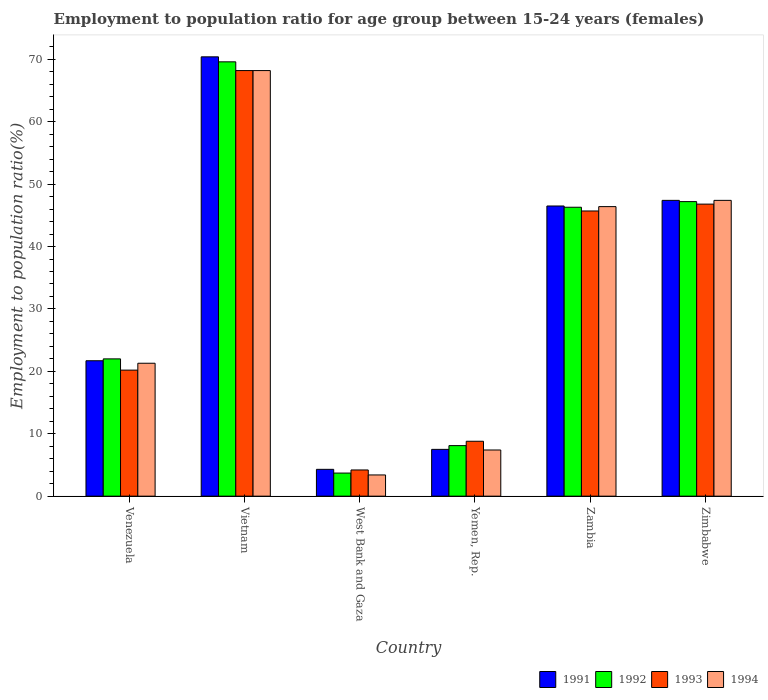How many groups of bars are there?
Make the answer very short. 6. Are the number of bars per tick equal to the number of legend labels?
Keep it short and to the point. Yes. Are the number of bars on each tick of the X-axis equal?
Make the answer very short. Yes. What is the label of the 4th group of bars from the left?
Offer a terse response. Yemen, Rep. What is the employment to population ratio in 1991 in Zimbabwe?
Your answer should be compact. 47.4. Across all countries, what is the maximum employment to population ratio in 1991?
Offer a very short reply. 70.4. Across all countries, what is the minimum employment to population ratio in 1991?
Your answer should be very brief. 4.3. In which country was the employment to population ratio in 1992 maximum?
Ensure brevity in your answer.  Vietnam. In which country was the employment to population ratio in 1991 minimum?
Offer a very short reply. West Bank and Gaza. What is the total employment to population ratio in 1991 in the graph?
Give a very brief answer. 197.8. What is the difference between the employment to population ratio in 1991 in Yemen, Rep. and that in Zambia?
Ensure brevity in your answer.  -39. What is the difference between the employment to population ratio in 1994 in Zambia and the employment to population ratio in 1992 in Zimbabwe?
Your answer should be compact. -0.8. What is the average employment to population ratio in 1993 per country?
Keep it short and to the point. 32.32. In how many countries, is the employment to population ratio in 1992 greater than 60 %?
Provide a short and direct response. 1. What is the ratio of the employment to population ratio in 1994 in Vietnam to that in Zimbabwe?
Ensure brevity in your answer.  1.44. What is the difference between the highest and the second highest employment to population ratio in 1992?
Provide a short and direct response. 23.3. What is the difference between the highest and the lowest employment to population ratio in 1991?
Your answer should be very brief. 66.1. Is the sum of the employment to population ratio in 1991 in Venezuela and Yemen, Rep. greater than the maximum employment to population ratio in 1992 across all countries?
Offer a terse response. No. How many bars are there?
Your response must be concise. 24. Are the values on the major ticks of Y-axis written in scientific E-notation?
Keep it short and to the point. No. Does the graph contain any zero values?
Provide a short and direct response. No. Does the graph contain grids?
Ensure brevity in your answer.  No. Where does the legend appear in the graph?
Ensure brevity in your answer.  Bottom right. How are the legend labels stacked?
Ensure brevity in your answer.  Horizontal. What is the title of the graph?
Your answer should be compact. Employment to population ratio for age group between 15-24 years (females). Does "1988" appear as one of the legend labels in the graph?
Your answer should be very brief. No. What is the Employment to population ratio(%) of 1991 in Venezuela?
Ensure brevity in your answer.  21.7. What is the Employment to population ratio(%) of 1992 in Venezuela?
Give a very brief answer. 22. What is the Employment to population ratio(%) in 1993 in Venezuela?
Your answer should be compact. 20.2. What is the Employment to population ratio(%) in 1994 in Venezuela?
Your answer should be very brief. 21.3. What is the Employment to population ratio(%) of 1991 in Vietnam?
Your answer should be very brief. 70.4. What is the Employment to population ratio(%) in 1992 in Vietnam?
Your answer should be very brief. 69.6. What is the Employment to population ratio(%) in 1993 in Vietnam?
Offer a very short reply. 68.2. What is the Employment to population ratio(%) in 1994 in Vietnam?
Provide a succinct answer. 68.2. What is the Employment to population ratio(%) of 1991 in West Bank and Gaza?
Ensure brevity in your answer.  4.3. What is the Employment to population ratio(%) of 1992 in West Bank and Gaza?
Your response must be concise. 3.7. What is the Employment to population ratio(%) of 1993 in West Bank and Gaza?
Make the answer very short. 4.2. What is the Employment to population ratio(%) of 1994 in West Bank and Gaza?
Make the answer very short. 3.4. What is the Employment to population ratio(%) of 1991 in Yemen, Rep.?
Offer a very short reply. 7.5. What is the Employment to population ratio(%) of 1992 in Yemen, Rep.?
Your response must be concise. 8.1. What is the Employment to population ratio(%) in 1993 in Yemen, Rep.?
Keep it short and to the point. 8.8. What is the Employment to population ratio(%) of 1994 in Yemen, Rep.?
Ensure brevity in your answer.  7.4. What is the Employment to population ratio(%) in 1991 in Zambia?
Your answer should be compact. 46.5. What is the Employment to population ratio(%) in 1992 in Zambia?
Your answer should be compact. 46.3. What is the Employment to population ratio(%) in 1993 in Zambia?
Your response must be concise. 45.7. What is the Employment to population ratio(%) of 1994 in Zambia?
Your answer should be very brief. 46.4. What is the Employment to population ratio(%) of 1991 in Zimbabwe?
Your response must be concise. 47.4. What is the Employment to population ratio(%) in 1992 in Zimbabwe?
Your answer should be compact. 47.2. What is the Employment to population ratio(%) in 1993 in Zimbabwe?
Ensure brevity in your answer.  46.8. What is the Employment to population ratio(%) in 1994 in Zimbabwe?
Provide a succinct answer. 47.4. Across all countries, what is the maximum Employment to population ratio(%) of 1991?
Provide a succinct answer. 70.4. Across all countries, what is the maximum Employment to population ratio(%) of 1992?
Offer a very short reply. 69.6. Across all countries, what is the maximum Employment to population ratio(%) in 1993?
Provide a short and direct response. 68.2. Across all countries, what is the maximum Employment to population ratio(%) of 1994?
Ensure brevity in your answer.  68.2. Across all countries, what is the minimum Employment to population ratio(%) of 1991?
Keep it short and to the point. 4.3. Across all countries, what is the minimum Employment to population ratio(%) in 1992?
Make the answer very short. 3.7. Across all countries, what is the minimum Employment to population ratio(%) of 1993?
Your response must be concise. 4.2. Across all countries, what is the minimum Employment to population ratio(%) of 1994?
Offer a terse response. 3.4. What is the total Employment to population ratio(%) in 1991 in the graph?
Your answer should be very brief. 197.8. What is the total Employment to population ratio(%) of 1992 in the graph?
Provide a short and direct response. 196.9. What is the total Employment to population ratio(%) in 1993 in the graph?
Offer a very short reply. 193.9. What is the total Employment to population ratio(%) of 1994 in the graph?
Your response must be concise. 194.1. What is the difference between the Employment to population ratio(%) of 1991 in Venezuela and that in Vietnam?
Your response must be concise. -48.7. What is the difference between the Employment to population ratio(%) of 1992 in Venezuela and that in Vietnam?
Make the answer very short. -47.6. What is the difference between the Employment to population ratio(%) of 1993 in Venezuela and that in Vietnam?
Make the answer very short. -48. What is the difference between the Employment to population ratio(%) of 1994 in Venezuela and that in Vietnam?
Your answer should be compact. -46.9. What is the difference between the Employment to population ratio(%) of 1994 in Venezuela and that in West Bank and Gaza?
Your answer should be compact. 17.9. What is the difference between the Employment to population ratio(%) of 1992 in Venezuela and that in Yemen, Rep.?
Offer a terse response. 13.9. What is the difference between the Employment to population ratio(%) in 1993 in Venezuela and that in Yemen, Rep.?
Provide a short and direct response. 11.4. What is the difference between the Employment to population ratio(%) of 1991 in Venezuela and that in Zambia?
Your answer should be compact. -24.8. What is the difference between the Employment to population ratio(%) of 1992 in Venezuela and that in Zambia?
Offer a terse response. -24.3. What is the difference between the Employment to population ratio(%) of 1993 in Venezuela and that in Zambia?
Your answer should be compact. -25.5. What is the difference between the Employment to population ratio(%) of 1994 in Venezuela and that in Zambia?
Your response must be concise. -25.1. What is the difference between the Employment to population ratio(%) of 1991 in Venezuela and that in Zimbabwe?
Your response must be concise. -25.7. What is the difference between the Employment to population ratio(%) of 1992 in Venezuela and that in Zimbabwe?
Provide a succinct answer. -25.2. What is the difference between the Employment to population ratio(%) of 1993 in Venezuela and that in Zimbabwe?
Provide a succinct answer. -26.6. What is the difference between the Employment to population ratio(%) of 1994 in Venezuela and that in Zimbabwe?
Provide a short and direct response. -26.1. What is the difference between the Employment to population ratio(%) of 1991 in Vietnam and that in West Bank and Gaza?
Your response must be concise. 66.1. What is the difference between the Employment to population ratio(%) of 1992 in Vietnam and that in West Bank and Gaza?
Your answer should be very brief. 65.9. What is the difference between the Employment to population ratio(%) of 1993 in Vietnam and that in West Bank and Gaza?
Provide a short and direct response. 64. What is the difference between the Employment to population ratio(%) of 1994 in Vietnam and that in West Bank and Gaza?
Your answer should be compact. 64.8. What is the difference between the Employment to population ratio(%) in 1991 in Vietnam and that in Yemen, Rep.?
Make the answer very short. 62.9. What is the difference between the Employment to population ratio(%) of 1992 in Vietnam and that in Yemen, Rep.?
Make the answer very short. 61.5. What is the difference between the Employment to population ratio(%) of 1993 in Vietnam and that in Yemen, Rep.?
Make the answer very short. 59.4. What is the difference between the Employment to population ratio(%) of 1994 in Vietnam and that in Yemen, Rep.?
Offer a very short reply. 60.8. What is the difference between the Employment to population ratio(%) in 1991 in Vietnam and that in Zambia?
Your answer should be very brief. 23.9. What is the difference between the Employment to population ratio(%) of 1992 in Vietnam and that in Zambia?
Your answer should be compact. 23.3. What is the difference between the Employment to population ratio(%) in 1994 in Vietnam and that in Zambia?
Ensure brevity in your answer.  21.8. What is the difference between the Employment to population ratio(%) of 1991 in Vietnam and that in Zimbabwe?
Offer a terse response. 23. What is the difference between the Employment to population ratio(%) of 1992 in Vietnam and that in Zimbabwe?
Your answer should be very brief. 22.4. What is the difference between the Employment to population ratio(%) in 1993 in Vietnam and that in Zimbabwe?
Your response must be concise. 21.4. What is the difference between the Employment to population ratio(%) of 1994 in Vietnam and that in Zimbabwe?
Your answer should be compact. 20.8. What is the difference between the Employment to population ratio(%) in 1992 in West Bank and Gaza and that in Yemen, Rep.?
Provide a succinct answer. -4.4. What is the difference between the Employment to population ratio(%) in 1994 in West Bank and Gaza and that in Yemen, Rep.?
Provide a short and direct response. -4. What is the difference between the Employment to population ratio(%) of 1991 in West Bank and Gaza and that in Zambia?
Your response must be concise. -42.2. What is the difference between the Employment to population ratio(%) of 1992 in West Bank and Gaza and that in Zambia?
Your response must be concise. -42.6. What is the difference between the Employment to population ratio(%) in 1993 in West Bank and Gaza and that in Zambia?
Ensure brevity in your answer.  -41.5. What is the difference between the Employment to population ratio(%) of 1994 in West Bank and Gaza and that in Zambia?
Make the answer very short. -43. What is the difference between the Employment to population ratio(%) of 1991 in West Bank and Gaza and that in Zimbabwe?
Provide a short and direct response. -43.1. What is the difference between the Employment to population ratio(%) in 1992 in West Bank and Gaza and that in Zimbabwe?
Your response must be concise. -43.5. What is the difference between the Employment to population ratio(%) of 1993 in West Bank and Gaza and that in Zimbabwe?
Provide a succinct answer. -42.6. What is the difference between the Employment to population ratio(%) in 1994 in West Bank and Gaza and that in Zimbabwe?
Provide a succinct answer. -44. What is the difference between the Employment to population ratio(%) in 1991 in Yemen, Rep. and that in Zambia?
Your answer should be very brief. -39. What is the difference between the Employment to population ratio(%) in 1992 in Yemen, Rep. and that in Zambia?
Provide a succinct answer. -38.2. What is the difference between the Employment to population ratio(%) of 1993 in Yemen, Rep. and that in Zambia?
Your answer should be very brief. -36.9. What is the difference between the Employment to population ratio(%) in 1994 in Yemen, Rep. and that in Zambia?
Your response must be concise. -39. What is the difference between the Employment to population ratio(%) of 1991 in Yemen, Rep. and that in Zimbabwe?
Keep it short and to the point. -39.9. What is the difference between the Employment to population ratio(%) in 1992 in Yemen, Rep. and that in Zimbabwe?
Your response must be concise. -39.1. What is the difference between the Employment to population ratio(%) in 1993 in Yemen, Rep. and that in Zimbabwe?
Offer a terse response. -38. What is the difference between the Employment to population ratio(%) in 1994 in Yemen, Rep. and that in Zimbabwe?
Ensure brevity in your answer.  -40. What is the difference between the Employment to population ratio(%) in 1992 in Zambia and that in Zimbabwe?
Offer a terse response. -0.9. What is the difference between the Employment to population ratio(%) in 1993 in Zambia and that in Zimbabwe?
Your answer should be compact. -1.1. What is the difference between the Employment to population ratio(%) of 1994 in Zambia and that in Zimbabwe?
Ensure brevity in your answer.  -1. What is the difference between the Employment to population ratio(%) in 1991 in Venezuela and the Employment to population ratio(%) in 1992 in Vietnam?
Your answer should be very brief. -47.9. What is the difference between the Employment to population ratio(%) in 1991 in Venezuela and the Employment to population ratio(%) in 1993 in Vietnam?
Your answer should be very brief. -46.5. What is the difference between the Employment to population ratio(%) of 1991 in Venezuela and the Employment to population ratio(%) of 1994 in Vietnam?
Your answer should be compact. -46.5. What is the difference between the Employment to population ratio(%) in 1992 in Venezuela and the Employment to population ratio(%) in 1993 in Vietnam?
Your answer should be very brief. -46.2. What is the difference between the Employment to population ratio(%) in 1992 in Venezuela and the Employment to population ratio(%) in 1994 in Vietnam?
Offer a terse response. -46.2. What is the difference between the Employment to population ratio(%) in 1993 in Venezuela and the Employment to population ratio(%) in 1994 in Vietnam?
Provide a short and direct response. -48. What is the difference between the Employment to population ratio(%) of 1992 in Venezuela and the Employment to population ratio(%) of 1994 in West Bank and Gaza?
Ensure brevity in your answer.  18.6. What is the difference between the Employment to population ratio(%) of 1991 in Venezuela and the Employment to population ratio(%) of 1992 in Yemen, Rep.?
Your response must be concise. 13.6. What is the difference between the Employment to population ratio(%) in 1991 in Venezuela and the Employment to population ratio(%) in 1994 in Yemen, Rep.?
Your answer should be very brief. 14.3. What is the difference between the Employment to population ratio(%) of 1993 in Venezuela and the Employment to population ratio(%) of 1994 in Yemen, Rep.?
Your answer should be compact. 12.8. What is the difference between the Employment to population ratio(%) in 1991 in Venezuela and the Employment to population ratio(%) in 1992 in Zambia?
Offer a terse response. -24.6. What is the difference between the Employment to population ratio(%) in 1991 in Venezuela and the Employment to population ratio(%) in 1994 in Zambia?
Your answer should be compact. -24.7. What is the difference between the Employment to population ratio(%) of 1992 in Venezuela and the Employment to population ratio(%) of 1993 in Zambia?
Provide a succinct answer. -23.7. What is the difference between the Employment to population ratio(%) of 1992 in Venezuela and the Employment to population ratio(%) of 1994 in Zambia?
Offer a terse response. -24.4. What is the difference between the Employment to population ratio(%) of 1993 in Venezuela and the Employment to population ratio(%) of 1994 in Zambia?
Ensure brevity in your answer.  -26.2. What is the difference between the Employment to population ratio(%) of 1991 in Venezuela and the Employment to population ratio(%) of 1992 in Zimbabwe?
Provide a succinct answer. -25.5. What is the difference between the Employment to population ratio(%) in 1991 in Venezuela and the Employment to population ratio(%) in 1993 in Zimbabwe?
Make the answer very short. -25.1. What is the difference between the Employment to population ratio(%) in 1991 in Venezuela and the Employment to population ratio(%) in 1994 in Zimbabwe?
Make the answer very short. -25.7. What is the difference between the Employment to population ratio(%) in 1992 in Venezuela and the Employment to population ratio(%) in 1993 in Zimbabwe?
Give a very brief answer. -24.8. What is the difference between the Employment to population ratio(%) in 1992 in Venezuela and the Employment to population ratio(%) in 1994 in Zimbabwe?
Ensure brevity in your answer.  -25.4. What is the difference between the Employment to population ratio(%) of 1993 in Venezuela and the Employment to population ratio(%) of 1994 in Zimbabwe?
Give a very brief answer. -27.2. What is the difference between the Employment to population ratio(%) of 1991 in Vietnam and the Employment to population ratio(%) of 1992 in West Bank and Gaza?
Your answer should be very brief. 66.7. What is the difference between the Employment to population ratio(%) in 1991 in Vietnam and the Employment to population ratio(%) in 1993 in West Bank and Gaza?
Make the answer very short. 66.2. What is the difference between the Employment to population ratio(%) of 1991 in Vietnam and the Employment to population ratio(%) of 1994 in West Bank and Gaza?
Give a very brief answer. 67. What is the difference between the Employment to population ratio(%) of 1992 in Vietnam and the Employment to population ratio(%) of 1993 in West Bank and Gaza?
Provide a short and direct response. 65.4. What is the difference between the Employment to population ratio(%) of 1992 in Vietnam and the Employment to population ratio(%) of 1994 in West Bank and Gaza?
Ensure brevity in your answer.  66.2. What is the difference between the Employment to population ratio(%) of 1993 in Vietnam and the Employment to population ratio(%) of 1994 in West Bank and Gaza?
Give a very brief answer. 64.8. What is the difference between the Employment to population ratio(%) in 1991 in Vietnam and the Employment to population ratio(%) in 1992 in Yemen, Rep.?
Your answer should be compact. 62.3. What is the difference between the Employment to population ratio(%) of 1991 in Vietnam and the Employment to population ratio(%) of 1993 in Yemen, Rep.?
Provide a succinct answer. 61.6. What is the difference between the Employment to population ratio(%) of 1992 in Vietnam and the Employment to population ratio(%) of 1993 in Yemen, Rep.?
Your response must be concise. 60.8. What is the difference between the Employment to population ratio(%) in 1992 in Vietnam and the Employment to population ratio(%) in 1994 in Yemen, Rep.?
Provide a succinct answer. 62.2. What is the difference between the Employment to population ratio(%) of 1993 in Vietnam and the Employment to population ratio(%) of 1994 in Yemen, Rep.?
Ensure brevity in your answer.  60.8. What is the difference between the Employment to population ratio(%) in 1991 in Vietnam and the Employment to population ratio(%) in 1992 in Zambia?
Provide a succinct answer. 24.1. What is the difference between the Employment to population ratio(%) of 1991 in Vietnam and the Employment to population ratio(%) of 1993 in Zambia?
Provide a short and direct response. 24.7. What is the difference between the Employment to population ratio(%) in 1992 in Vietnam and the Employment to population ratio(%) in 1993 in Zambia?
Make the answer very short. 23.9. What is the difference between the Employment to population ratio(%) in 1992 in Vietnam and the Employment to population ratio(%) in 1994 in Zambia?
Your response must be concise. 23.2. What is the difference between the Employment to population ratio(%) of 1993 in Vietnam and the Employment to population ratio(%) of 1994 in Zambia?
Your response must be concise. 21.8. What is the difference between the Employment to population ratio(%) of 1991 in Vietnam and the Employment to population ratio(%) of 1992 in Zimbabwe?
Give a very brief answer. 23.2. What is the difference between the Employment to population ratio(%) of 1991 in Vietnam and the Employment to population ratio(%) of 1993 in Zimbabwe?
Your answer should be very brief. 23.6. What is the difference between the Employment to population ratio(%) of 1992 in Vietnam and the Employment to population ratio(%) of 1993 in Zimbabwe?
Make the answer very short. 22.8. What is the difference between the Employment to population ratio(%) in 1992 in Vietnam and the Employment to population ratio(%) in 1994 in Zimbabwe?
Offer a terse response. 22.2. What is the difference between the Employment to population ratio(%) of 1993 in Vietnam and the Employment to population ratio(%) of 1994 in Zimbabwe?
Give a very brief answer. 20.8. What is the difference between the Employment to population ratio(%) in 1991 in West Bank and Gaza and the Employment to population ratio(%) in 1992 in Zambia?
Your response must be concise. -42. What is the difference between the Employment to population ratio(%) of 1991 in West Bank and Gaza and the Employment to population ratio(%) of 1993 in Zambia?
Your answer should be very brief. -41.4. What is the difference between the Employment to population ratio(%) in 1991 in West Bank and Gaza and the Employment to population ratio(%) in 1994 in Zambia?
Your response must be concise. -42.1. What is the difference between the Employment to population ratio(%) in 1992 in West Bank and Gaza and the Employment to population ratio(%) in 1993 in Zambia?
Provide a short and direct response. -42. What is the difference between the Employment to population ratio(%) of 1992 in West Bank and Gaza and the Employment to population ratio(%) of 1994 in Zambia?
Your answer should be compact. -42.7. What is the difference between the Employment to population ratio(%) in 1993 in West Bank and Gaza and the Employment to population ratio(%) in 1994 in Zambia?
Provide a succinct answer. -42.2. What is the difference between the Employment to population ratio(%) of 1991 in West Bank and Gaza and the Employment to population ratio(%) of 1992 in Zimbabwe?
Your response must be concise. -42.9. What is the difference between the Employment to population ratio(%) of 1991 in West Bank and Gaza and the Employment to population ratio(%) of 1993 in Zimbabwe?
Your response must be concise. -42.5. What is the difference between the Employment to population ratio(%) in 1991 in West Bank and Gaza and the Employment to population ratio(%) in 1994 in Zimbabwe?
Offer a terse response. -43.1. What is the difference between the Employment to population ratio(%) in 1992 in West Bank and Gaza and the Employment to population ratio(%) in 1993 in Zimbabwe?
Ensure brevity in your answer.  -43.1. What is the difference between the Employment to population ratio(%) of 1992 in West Bank and Gaza and the Employment to population ratio(%) of 1994 in Zimbabwe?
Provide a succinct answer. -43.7. What is the difference between the Employment to population ratio(%) in 1993 in West Bank and Gaza and the Employment to population ratio(%) in 1994 in Zimbabwe?
Provide a succinct answer. -43.2. What is the difference between the Employment to population ratio(%) in 1991 in Yemen, Rep. and the Employment to population ratio(%) in 1992 in Zambia?
Ensure brevity in your answer.  -38.8. What is the difference between the Employment to population ratio(%) in 1991 in Yemen, Rep. and the Employment to population ratio(%) in 1993 in Zambia?
Provide a short and direct response. -38.2. What is the difference between the Employment to population ratio(%) of 1991 in Yemen, Rep. and the Employment to population ratio(%) of 1994 in Zambia?
Make the answer very short. -38.9. What is the difference between the Employment to population ratio(%) of 1992 in Yemen, Rep. and the Employment to population ratio(%) of 1993 in Zambia?
Your response must be concise. -37.6. What is the difference between the Employment to population ratio(%) of 1992 in Yemen, Rep. and the Employment to population ratio(%) of 1994 in Zambia?
Provide a succinct answer. -38.3. What is the difference between the Employment to population ratio(%) of 1993 in Yemen, Rep. and the Employment to population ratio(%) of 1994 in Zambia?
Your answer should be compact. -37.6. What is the difference between the Employment to population ratio(%) of 1991 in Yemen, Rep. and the Employment to population ratio(%) of 1992 in Zimbabwe?
Provide a succinct answer. -39.7. What is the difference between the Employment to population ratio(%) of 1991 in Yemen, Rep. and the Employment to population ratio(%) of 1993 in Zimbabwe?
Your response must be concise. -39.3. What is the difference between the Employment to population ratio(%) of 1991 in Yemen, Rep. and the Employment to population ratio(%) of 1994 in Zimbabwe?
Keep it short and to the point. -39.9. What is the difference between the Employment to population ratio(%) in 1992 in Yemen, Rep. and the Employment to population ratio(%) in 1993 in Zimbabwe?
Provide a short and direct response. -38.7. What is the difference between the Employment to population ratio(%) of 1992 in Yemen, Rep. and the Employment to population ratio(%) of 1994 in Zimbabwe?
Give a very brief answer. -39.3. What is the difference between the Employment to population ratio(%) in 1993 in Yemen, Rep. and the Employment to population ratio(%) in 1994 in Zimbabwe?
Your answer should be compact. -38.6. What is the difference between the Employment to population ratio(%) of 1991 in Zambia and the Employment to population ratio(%) of 1993 in Zimbabwe?
Give a very brief answer. -0.3. What is the difference between the Employment to population ratio(%) in 1992 in Zambia and the Employment to population ratio(%) in 1994 in Zimbabwe?
Give a very brief answer. -1.1. What is the average Employment to population ratio(%) of 1991 per country?
Your answer should be very brief. 32.97. What is the average Employment to population ratio(%) in 1992 per country?
Make the answer very short. 32.82. What is the average Employment to population ratio(%) in 1993 per country?
Your answer should be very brief. 32.32. What is the average Employment to population ratio(%) of 1994 per country?
Your answer should be compact. 32.35. What is the difference between the Employment to population ratio(%) of 1991 and Employment to population ratio(%) of 1992 in Venezuela?
Your response must be concise. -0.3. What is the difference between the Employment to population ratio(%) of 1991 and Employment to population ratio(%) of 1994 in Venezuela?
Provide a short and direct response. 0.4. What is the difference between the Employment to population ratio(%) in 1992 and Employment to population ratio(%) in 1993 in Venezuela?
Keep it short and to the point. 1.8. What is the difference between the Employment to population ratio(%) in 1993 and Employment to population ratio(%) in 1994 in Venezuela?
Make the answer very short. -1.1. What is the difference between the Employment to population ratio(%) of 1991 and Employment to population ratio(%) of 1993 in Vietnam?
Your response must be concise. 2.2. What is the difference between the Employment to population ratio(%) in 1992 and Employment to population ratio(%) in 1994 in Vietnam?
Your response must be concise. 1.4. What is the difference between the Employment to population ratio(%) of 1991 and Employment to population ratio(%) of 1994 in West Bank and Gaza?
Give a very brief answer. 0.9. What is the difference between the Employment to population ratio(%) of 1991 and Employment to population ratio(%) of 1992 in Yemen, Rep.?
Provide a succinct answer. -0.6. What is the difference between the Employment to population ratio(%) in 1993 and Employment to population ratio(%) in 1994 in Yemen, Rep.?
Keep it short and to the point. 1.4. What is the difference between the Employment to population ratio(%) of 1991 and Employment to population ratio(%) of 1994 in Zambia?
Offer a terse response. 0.1. What is the difference between the Employment to population ratio(%) in 1992 and Employment to population ratio(%) in 1993 in Zambia?
Your response must be concise. 0.6. What is the difference between the Employment to population ratio(%) of 1991 and Employment to population ratio(%) of 1992 in Zimbabwe?
Provide a succinct answer. 0.2. What is the difference between the Employment to population ratio(%) of 1991 and Employment to population ratio(%) of 1993 in Zimbabwe?
Offer a terse response. 0.6. What is the ratio of the Employment to population ratio(%) in 1991 in Venezuela to that in Vietnam?
Ensure brevity in your answer.  0.31. What is the ratio of the Employment to population ratio(%) of 1992 in Venezuela to that in Vietnam?
Your answer should be very brief. 0.32. What is the ratio of the Employment to population ratio(%) of 1993 in Venezuela to that in Vietnam?
Ensure brevity in your answer.  0.3. What is the ratio of the Employment to population ratio(%) of 1994 in Venezuela to that in Vietnam?
Your response must be concise. 0.31. What is the ratio of the Employment to population ratio(%) in 1991 in Venezuela to that in West Bank and Gaza?
Keep it short and to the point. 5.05. What is the ratio of the Employment to population ratio(%) in 1992 in Venezuela to that in West Bank and Gaza?
Give a very brief answer. 5.95. What is the ratio of the Employment to population ratio(%) of 1993 in Venezuela to that in West Bank and Gaza?
Keep it short and to the point. 4.81. What is the ratio of the Employment to population ratio(%) of 1994 in Venezuela to that in West Bank and Gaza?
Your response must be concise. 6.26. What is the ratio of the Employment to population ratio(%) in 1991 in Venezuela to that in Yemen, Rep.?
Offer a very short reply. 2.89. What is the ratio of the Employment to population ratio(%) of 1992 in Venezuela to that in Yemen, Rep.?
Provide a succinct answer. 2.72. What is the ratio of the Employment to population ratio(%) in 1993 in Venezuela to that in Yemen, Rep.?
Your answer should be very brief. 2.3. What is the ratio of the Employment to population ratio(%) in 1994 in Venezuela to that in Yemen, Rep.?
Make the answer very short. 2.88. What is the ratio of the Employment to population ratio(%) of 1991 in Venezuela to that in Zambia?
Ensure brevity in your answer.  0.47. What is the ratio of the Employment to population ratio(%) of 1992 in Venezuela to that in Zambia?
Ensure brevity in your answer.  0.48. What is the ratio of the Employment to population ratio(%) in 1993 in Venezuela to that in Zambia?
Give a very brief answer. 0.44. What is the ratio of the Employment to population ratio(%) in 1994 in Venezuela to that in Zambia?
Your response must be concise. 0.46. What is the ratio of the Employment to population ratio(%) in 1991 in Venezuela to that in Zimbabwe?
Provide a succinct answer. 0.46. What is the ratio of the Employment to population ratio(%) of 1992 in Venezuela to that in Zimbabwe?
Keep it short and to the point. 0.47. What is the ratio of the Employment to population ratio(%) of 1993 in Venezuela to that in Zimbabwe?
Provide a succinct answer. 0.43. What is the ratio of the Employment to population ratio(%) of 1994 in Venezuela to that in Zimbabwe?
Ensure brevity in your answer.  0.45. What is the ratio of the Employment to population ratio(%) in 1991 in Vietnam to that in West Bank and Gaza?
Make the answer very short. 16.37. What is the ratio of the Employment to population ratio(%) in 1992 in Vietnam to that in West Bank and Gaza?
Provide a short and direct response. 18.81. What is the ratio of the Employment to population ratio(%) of 1993 in Vietnam to that in West Bank and Gaza?
Provide a succinct answer. 16.24. What is the ratio of the Employment to population ratio(%) of 1994 in Vietnam to that in West Bank and Gaza?
Your response must be concise. 20.06. What is the ratio of the Employment to population ratio(%) of 1991 in Vietnam to that in Yemen, Rep.?
Make the answer very short. 9.39. What is the ratio of the Employment to population ratio(%) in 1992 in Vietnam to that in Yemen, Rep.?
Your answer should be very brief. 8.59. What is the ratio of the Employment to population ratio(%) of 1993 in Vietnam to that in Yemen, Rep.?
Your answer should be compact. 7.75. What is the ratio of the Employment to population ratio(%) in 1994 in Vietnam to that in Yemen, Rep.?
Your answer should be very brief. 9.22. What is the ratio of the Employment to population ratio(%) in 1991 in Vietnam to that in Zambia?
Provide a succinct answer. 1.51. What is the ratio of the Employment to population ratio(%) in 1992 in Vietnam to that in Zambia?
Your response must be concise. 1.5. What is the ratio of the Employment to population ratio(%) in 1993 in Vietnam to that in Zambia?
Make the answer very short. 1.49. What is the ratio of the Employment to population ratio(%) of 1994 in Vietnam to that in Zambia?
Offer a very short reply. 1.47. What is the ratio of the Employment to population ratio(%) in 1991 in Vietnam to that in Zimbabwe?
Offer a terse response. 1.49. What is the ratio of the Employment to population ratio(%) of 1992 in Vietnam to that in Zimbabwe?
Offer a very short reply. 1.47. What is the ratio of the Employment to population ratio(%) of 1993 in Vietnam to that in Zimbabwe?
Offer a very short reply. 1.46. What is the ratio of the Employment to population ratio(%) in 1994 in Vietnam to that in Zimbabwe?
Your response must be concise. 1.44. What is the ratio of the Employment to population ratio(%) in 1991 in West Bank and Gaza to that in Yemen, Rep.?
Provide a succinct answer. 0.57. What is the ratio of the Employment to population ratio(%) of 1992 in West Bank and Gaza to that in Yemen, Rep.?
Ensure brevity in your answer.  0.46. What is the ratio of the Employment to population ratio(%) in 1993 in West Bank and Gaza to that in Yemen, Rep.?
Give a very brief answer. 0.48. What is the ratio of the Employment to population ratio(%) in 1994 in West Bank and Gaza to that in Yemen, Rep.?
Keep it short and to the point. 0.46. What is the ratio of the Employment to population ratio(%) of 1991 in West Bank and Gaza to that in Zambia?
Ensure brevity in your answer.  0.09. What is the ratio of the Employment to population ratio(%) of 1992 in West Bank and Gaza to that in Zambia?
Your answer should be very brief. 0.08. What is the ratio of the Employment to population ratio(%) in 1993 in West Bank and Gaza to that in Zambia?
Your answer should be compact. 0.09. What is the ratio of the Employment to population ratio(%) of 1994 in West Bank and Gaza to that in Zambia?
Provide a succinct answer. 0.07. What is the ratio of the Employment to population ratio(%) of 1991 in West Bank and Gaza to that in Zimbabwe?
Your response must be concise. 0.09. What is the ratio of the Employment to population ratio(%) of 1992 in West Bank and Gaza to that in Zimbabwe?
Give a very brief answer. 0.08. What is the ratio of the Employment to population ratio(%) of 1993 in West Bank and Gaza to that in Zimbabwe?
Offer a terse response. 0.09. What is the ratio of the Employment to population ratio(%) in 1994 in West Bank and Gaza to that in Zimbabwe?
Your response must be concise. 0.07. What is the ratio of the Employment to population ratio(%) in 1991 in Yemen, Rep. to that in Zambia?
Give a very brief answer. 0.16. What is the ratio of the Employment to population ratio(%) in 1992 in Yemen, Rep. to that in Zambia?
Provide a short and direct response. 0.17. What is the ratio of the Employment to population ratio(%) of 1993 in Yemen, Rep. to that in Zambia?
Keep it short and to the point. 0.19. What is the ratio of the Employment to population ratio(%) of 1994 in Yemen, Rep. to that in Zambia?
Ensure brevity in your answer.  0.16. What is the ratio of the Employment to population ratio(%) in 1991 in Yemen, Rep. to that in Zimbabwe?
Offer a very short reply. 0.16. What is the ratio of the Employment to population ratio(%) of 1992 in Yemen, Rep. to that in Zimbabwe?
Make the answer very short. 0.17. What is the ratio of the Employment to population ratio(%) in 1993 in Yemen, Rep. to that in Zimbabwe?
Make the answer very short. 0.19. What is the ratio of the Employment to population ratio(%) of 1994 in Yemen, Rep. to that in Zimbabwe?
Ensure brevity in your answer.  0.16. What is the ratio of the Employment to population ratio(%) of 1992 in Zambia to that in Zimbabwe?
Give a very brief answer. 0.98. What is the ratio of the Employment to population ratio(%) of 1993 in Zambia to that in Zimbabwe?
Your answer should be very brief. 0.98. What is the ratio of the Employment to population ratio(%) in 1994 in Zambia to that in Zimbabwe?
Provide a succinct answer. 0.98. What is the difference between the highest and the second highest Employment to population ratio(%) in 1992?
Your answer should be compact. 22.4. What is the difference between the highest and the second highest Employment to population ratio(%) in 1993?
Keep it short and to the point. 21.4. What is the difference between the highest and the second highest Employment to population ratio(%) of 1994?
Your response must be concise. 20.8. What is the difference between the highest and the lowest Employment to population ratio(%) of 1991?
Your answer should be very brief. 66.1. What is the difference between the highest and the lowest Employment to population ratio(%) in 1992?
Your response must be concise. 65.9. What is the difference between the highest and the lowest Employment to population ratio(%) in 1993?
Your answer should be compact. 64. What is the difference between the highest and the lowest Employment to population ratio(%) in 1994?
Keep it short and to the point. 64.8. 